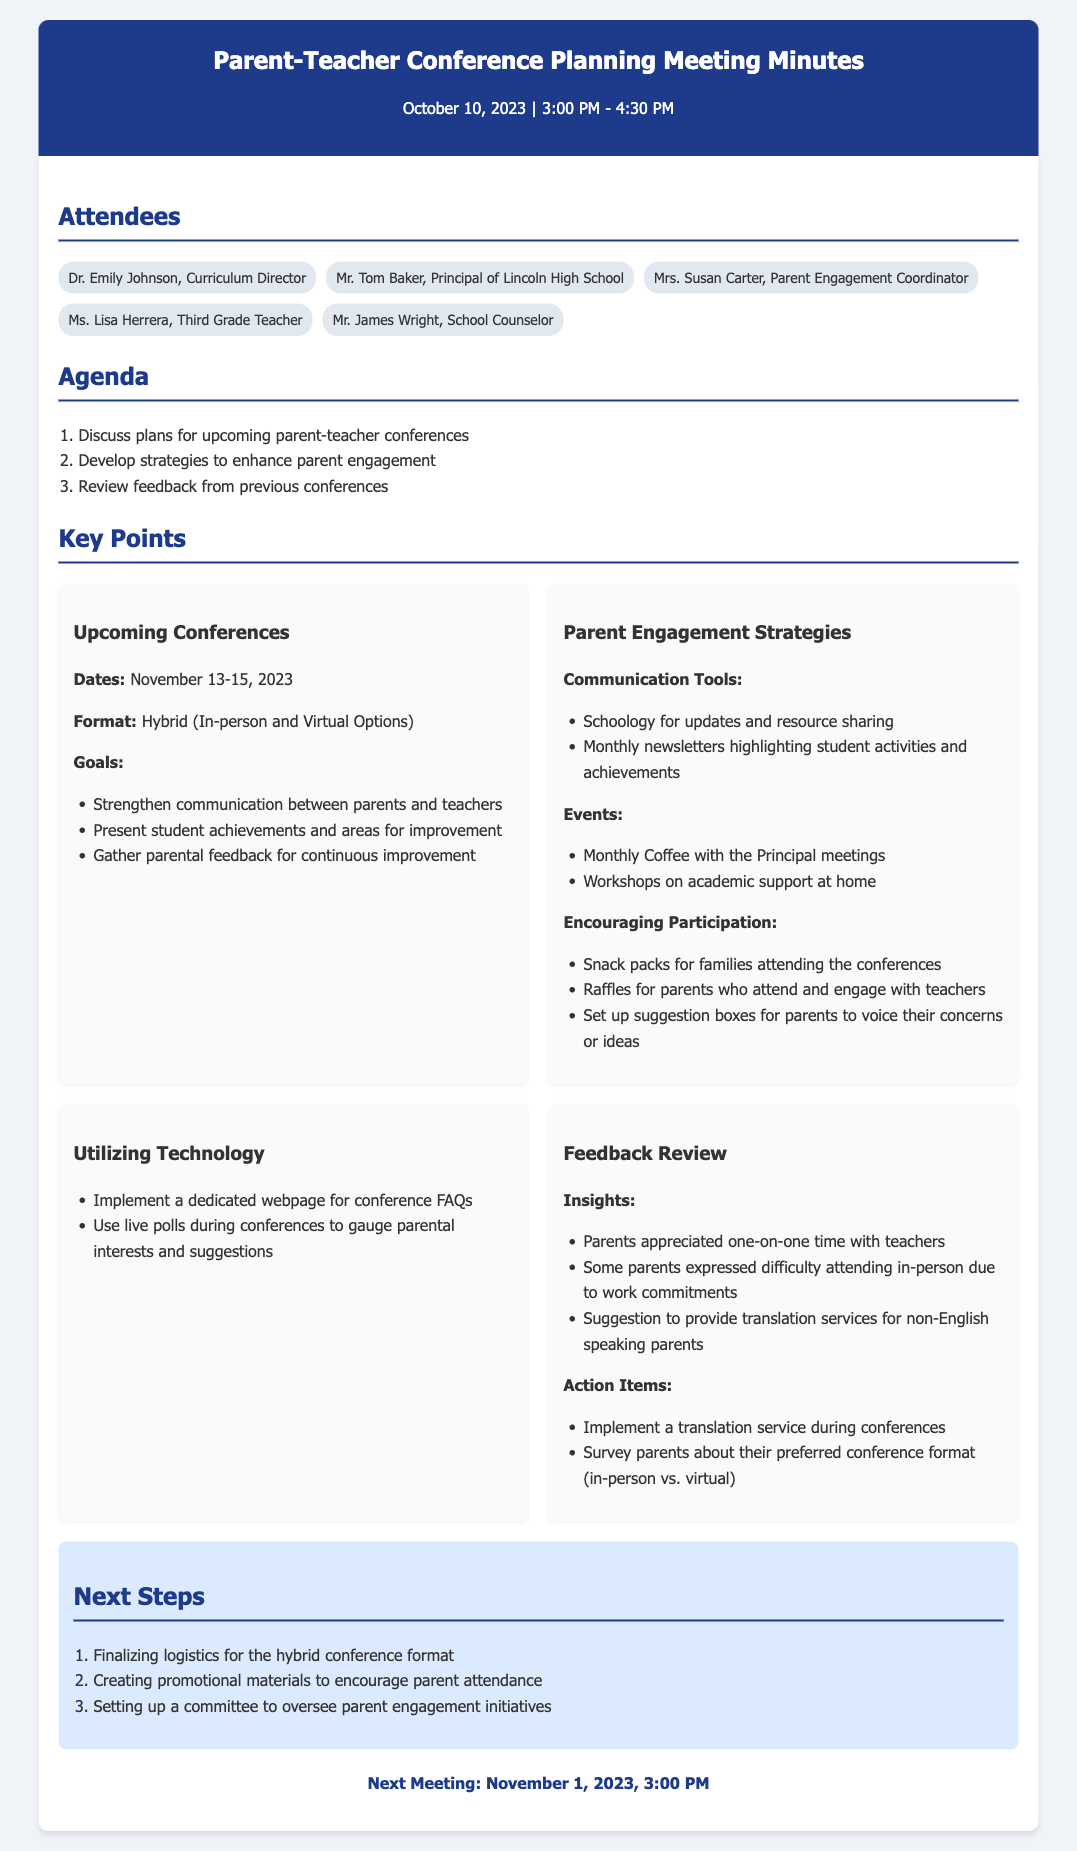what are the dates for the upcoming conferences? The document specifies that the upcoming conferences are scheduled for November 13-15, 2023.
Answer: November 13-15, 2023 what is the format of the upcoming conferences? The meeting minutes indicate that the format of the conferences will be hybrid, offering both in-person and virtual options.
Answer: Hybrid (In-person and Virtual Options) who is the Parent Engagement Coordinator? The document lists Mrs. Susan Carter as the Parent Engagement Coordinator among the attendees.
Answer: Mrs. Susan Carter what is one of the goals for the conferences? The document mentions multiple goals, one of which is to strengthen communication between parents and teachers.
Answer: Strengthen communication between parents and teachers what strategy is suggested to encourage participation from parents? The minutes highlight several strategies, including providing snack packs for families attending the conferences.
Answer: Snack packs for families attending the conferences how are parents’ preferences for conference format being assessed? The document states that a survey will be conducted to inquire about parents' preferred conference format, either in-person or virtual.
Answer: Survey parents about their preferred conference format what was a concern raised by parents in previous conferences? The document mentions that some parents expressed difficulty attending in-person due to work commitments.
Answer: Difficulty attending in-person due to work commitments what is scheduled to be discussed in the next meeting? The next meeting is focused on finalizing logistics for the hybrid conference format, among other items.
Answer: Finalizing logistics for the hybrid conference format 